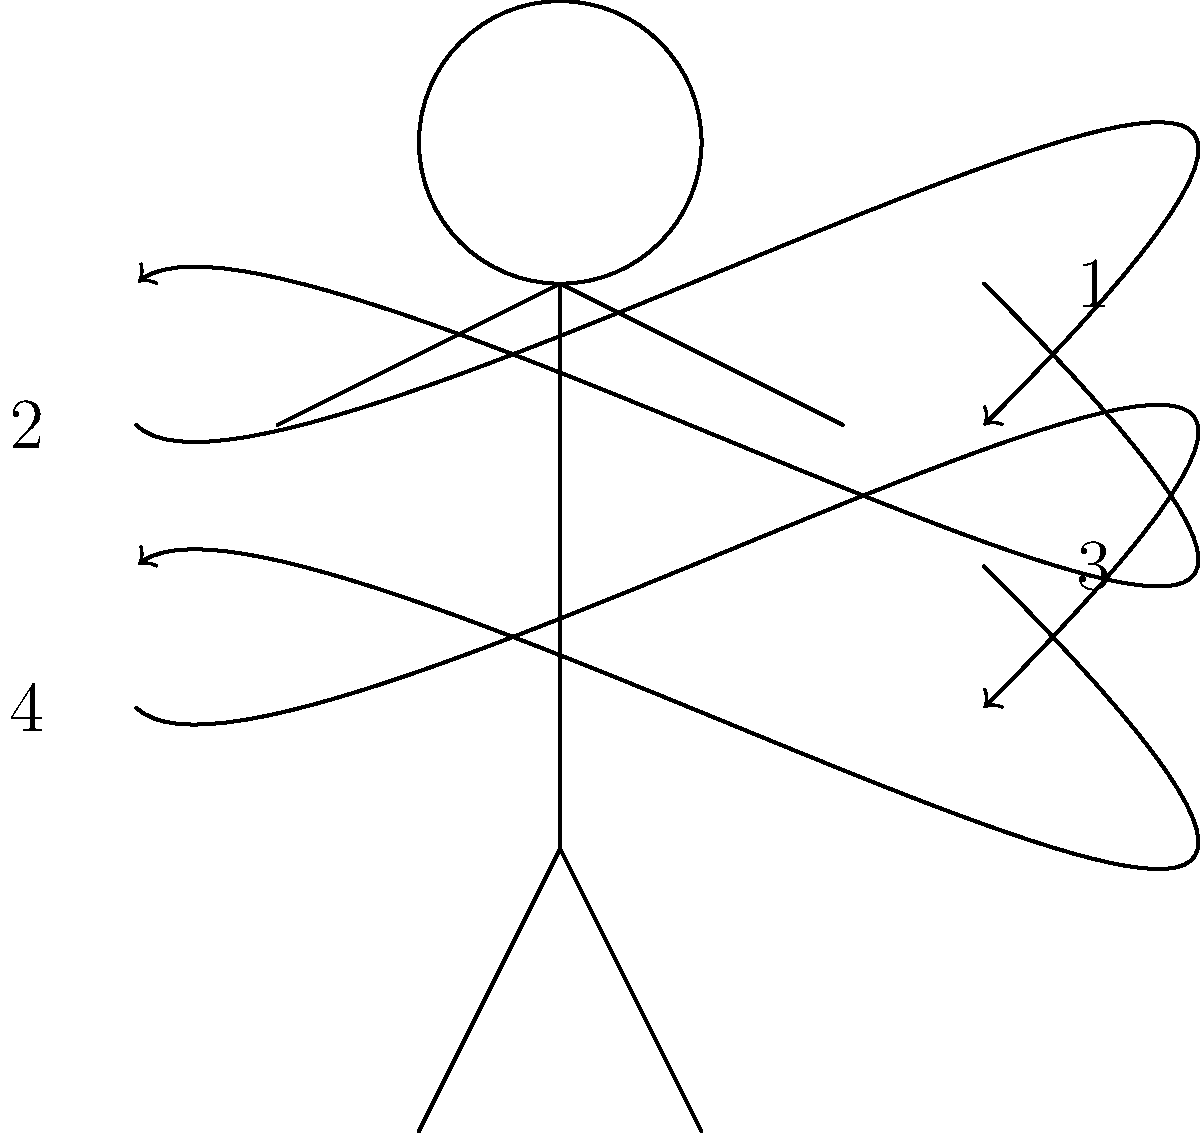In a soccer throw-in, the kinetic chain involves a sequence of body movements. Based on the diagram, which numbered arrow represents the final movement in the kinetic chain that transfers energy to the ball? To understand the kinetic chain in a soccer throw-in, let's break down the sequence of movements:

1. The kinetic chain typically starts from the ground up, involving larger muscle groups first.

2. Arrow 1 represents the initial movement, likely the hip rotation and trunk flexion. This movement generates the initial power for the throw.

3. Arrow 2 shows the next phase, which is probably the shoulder rotation and upper arm movement. This continues to build up energy in the kinetic chain.

4. Arrow 3 indicates the elbow extension, further transferring the energy up the kinetic chain.

5. Finally, arrow 4 represents the wrist and hand movement, which is the last link in the chain before the ball is released.

The kinetic chain works by transferring energy from larger body segments to smaller ones, increasing the speed of the movement. In a throw-in, this allows for maximum velocity to be imparted to the ball at the point of release.

Therefore, arrow 4, representing the wrist and hand movement, is the final movement in the kinetic chain that transfers energy to the ball before release.
Answer: 4 